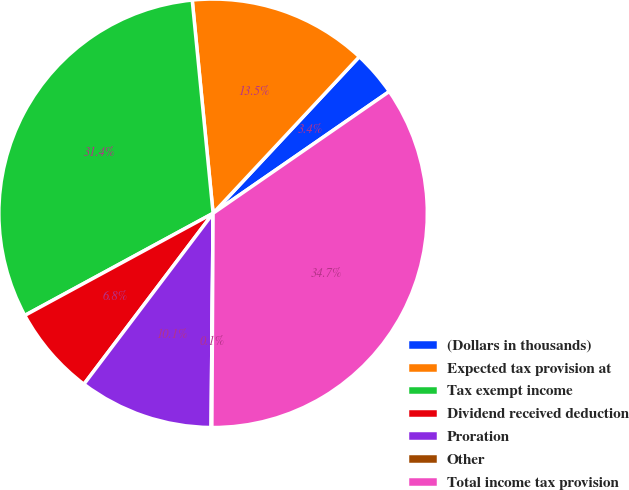<chart> <loc_0><loc_0><loc_500><loc_500><pie_chart><fcel>(Dollars in thousands)<fcel>Expected tax provision at<fcel>Tax exempt income<fcel>Dividend received deduction<fcel>Proration<fcel>Other<fcel>Total income tax provision<nl><fcel>3.42%<fcel>13.51%<fcel>31.36%<fcel>6.79%<fcel>10.15%<fcel>0.06%<fcel>34.72%<nl></chart> 